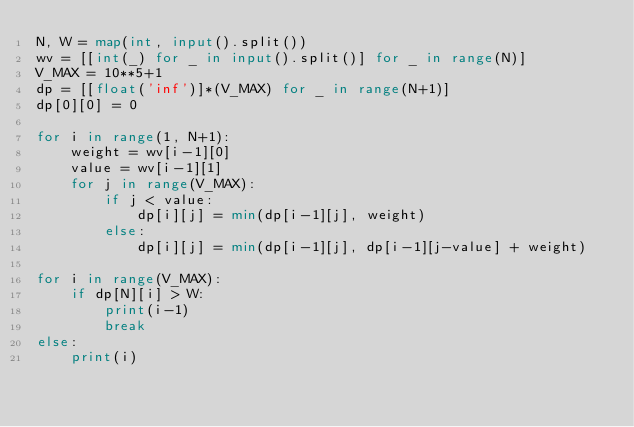<code> <loc_0><loc_0><loc_500><loc_500><_Python_>N, W = map(int, input().split())
wv = [[int(_) for _ in input().split()] for _ in range(N)]
V_MAX = 10**5+1
dp = [[float('inf')]*(V_MAX) for _ in range(N+1)]
dp[0][0] = 0

for i in range(1, N+1):
    weight = wv[i-1][0]
    value = wv[i-1][1]
    for j in range(V_MAX):
        if j < value:
            dp[i][j] = min(dp[i-1][j], weight)
        else:
            dp[i][j] = min(dp[i-1][j], dp[i-1][j-value] + weight)

for i in range(V_MAX):
    if dp[N][i] > W:
        print(i-1)
        break
else:
    print(i)</code> 